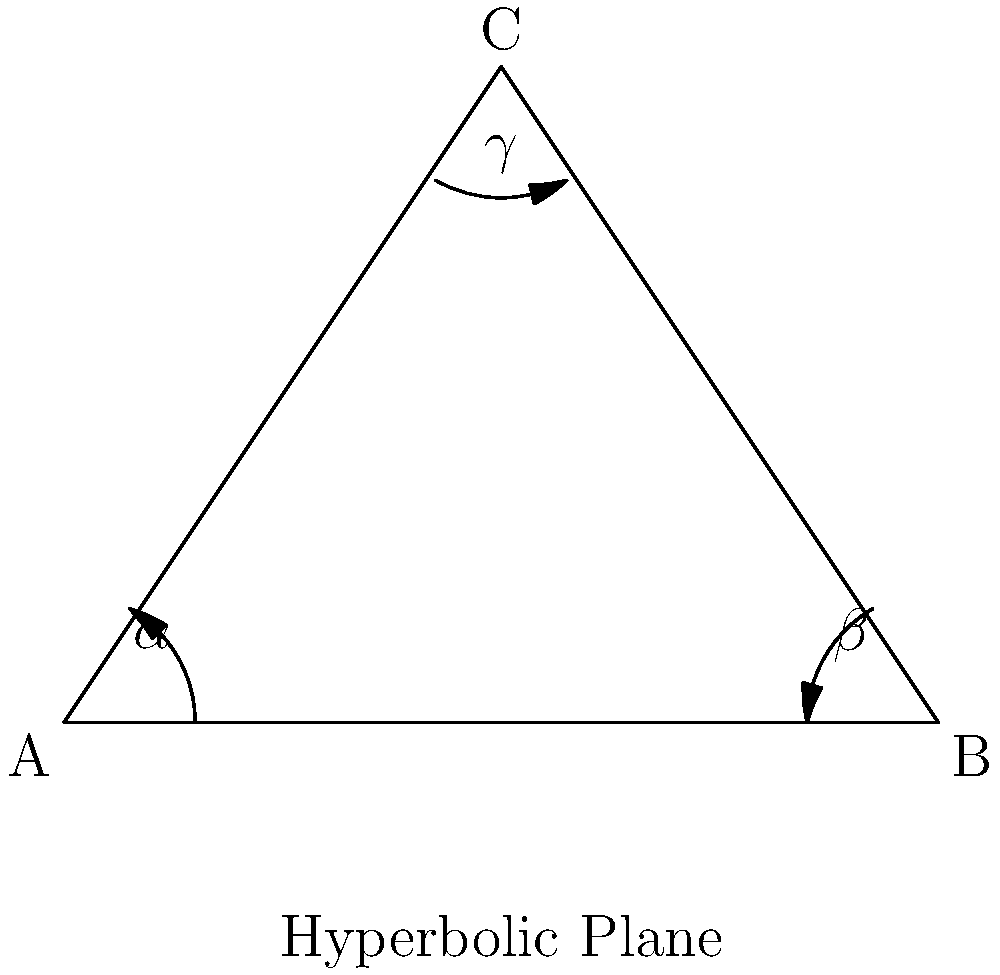In a hyperbolic plane, the angle sum of a triangle is always less than 180°. Consider a triangle ABC in a hyperbolic plane with angles $\alpha$, $\beta$, and $\gamma$. If the difference between 180° and the angle sum of this triangle is 30°, express the area of the triangle in terms of $\pi$. Let's approach this step-by-step:

1) In Euclidean geometry, the angle sum of a triangle is always 180°. However, in hyperbolic geometry, this sum is always less than 180°.

2) The difference between 180° and the angle sum of a hyperbolic triangle is called the defect of the triangle.

3) In this case, we're told that the defect is 30°. So we can write:

   $180° - (\alpha + \beta + \gamma) = 30°$

4) In hyperbolic geometry, there's a fundamental relationship between the area of a triangle and its defect. This relationship is given by the Gauss-Bonnet theorem:

   $Area = k(180° - (\alpha + \beta + \gamma))$

   where $k$ is a constant that depends on the curvature of the hyperbolic plane.

5) In most standard hyperbolic models (like the Poincaré disk model), this constant $k$ is chosen such that:

   $k = \frac{\pi}{180°}$

6) Substituting this and our known defect into the area formula:

   $Area = \frac{\pi}{180°} * 30°$

7) Simplifying:

   $Area = \frac{\pi}{6}$

Thus, the area of the triangle is $\frac{\pi}{6}$.
Answer: $\frac{\pi}{6}$ 